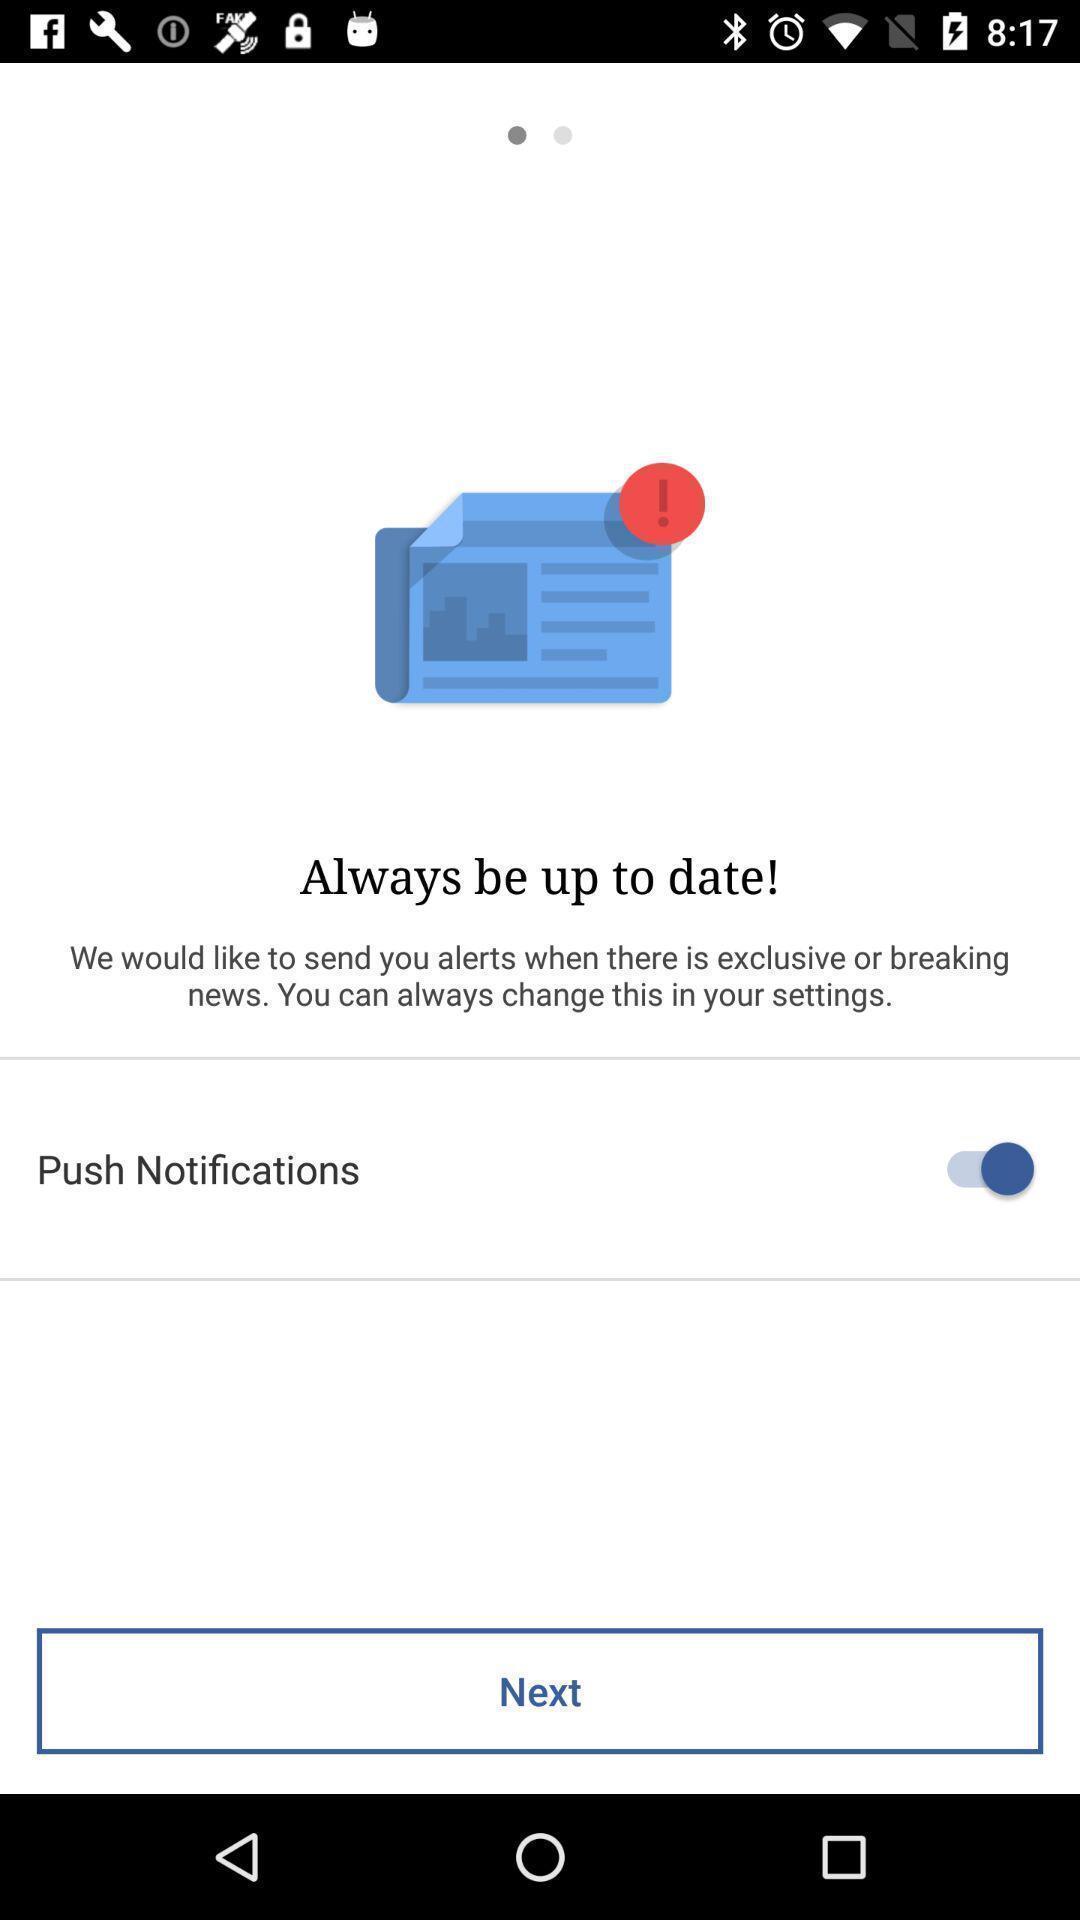Describe this image in words. Push notifications in the always be up to date. 